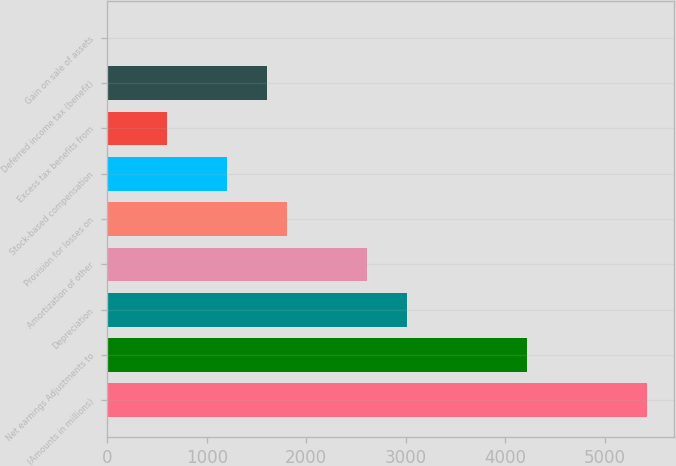Convert chart. <chart><loc_0><loc_0><loc_500><loc_500><bar_chart><fcel>(Amounts in millions)<fcel>Net earnings Adjustments to<fcel>Depreciation<fcel>Amortization of other<fcel>Provision for losses on<fcel>Stock-based compensation<fcel>Excess tax benefits from<fcel>Deferred income tax (benefit)<fcel>Gain on sale of assets<nl><fcel>5426.66<fcel>4220.78<fcel>3014.9<fcel>2612.94<fcel>1809.02<fcel>1206.08<fcel>603.14<fcel>1608.04<fcel>0.2<nl></chart> 